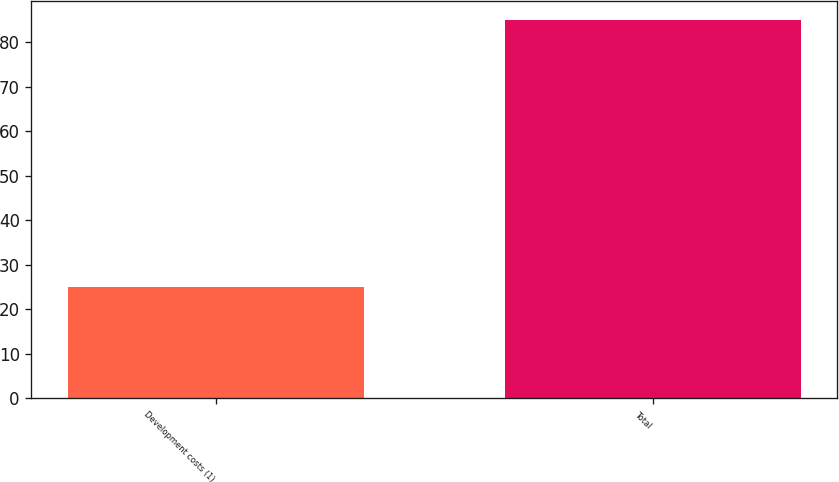Convert chart to OTSL. <chart><loc_0><loc_0><loc_500><loc_500><bar_chart><fcel>Development costs (1)<fcel>Total<nl><fcel>25<fcel>85<nl></chart> 